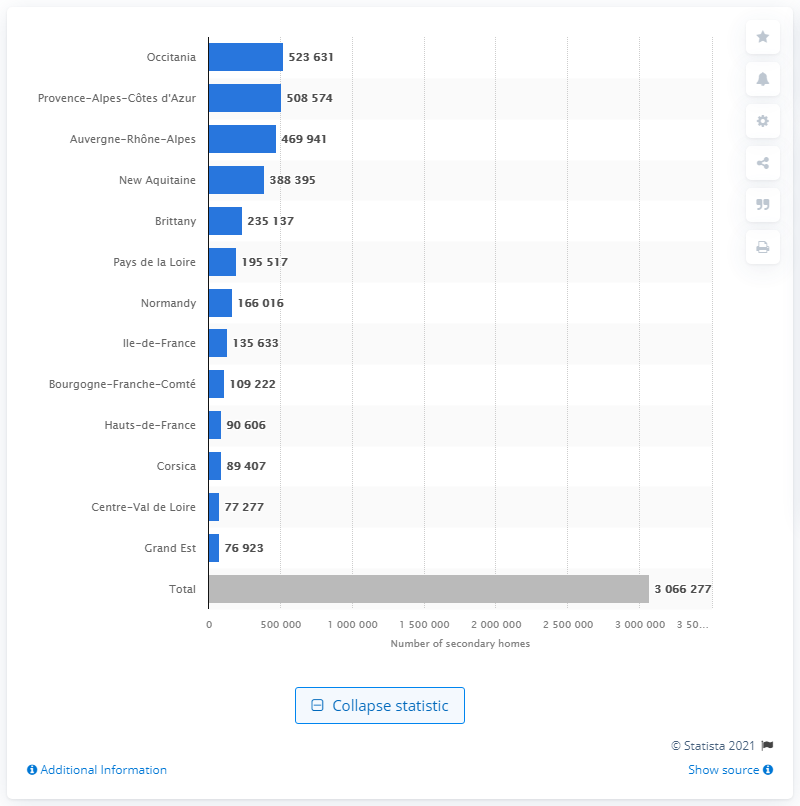Identify some key points in this picture. According to data, Occitania, a region in France, had the highest number of secondary residences. In 2015, the French region with the fewest second homes was Grand Est. 